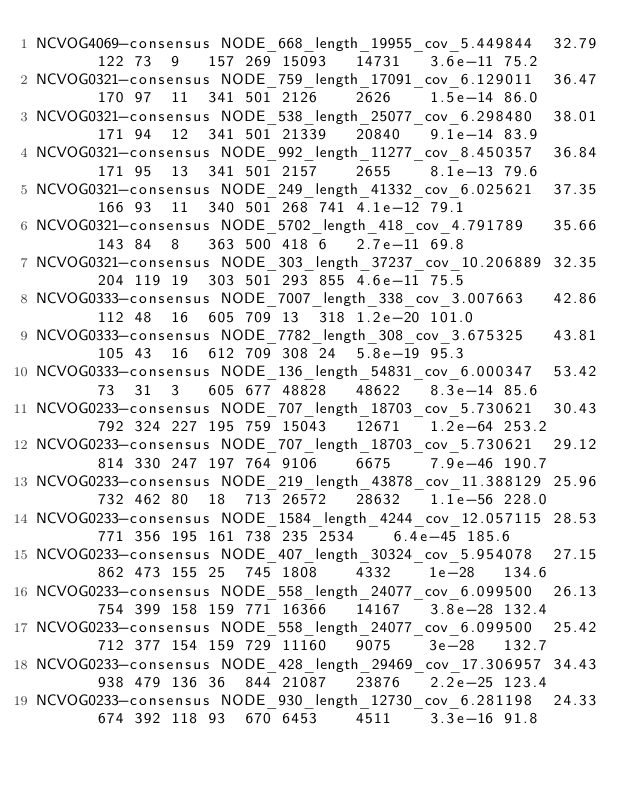Convert code to text. <code><loc_0><loc_0><loc_500><loc_500><_SQL_>NCVOG4069-consensus	NODE_668_length_19955_cov_5.449844	32.79	122	73	9	157	269	15093	14731	3.6e-11	75.2
NCVOG0321-consensus	NODE_759_length_17091_cov_6.129011	36.47	170	97	11	341	501	2126	2626	1.5e-14	86.0
NCVOG0321-consensus	NODE_538_length_25077_cov_6.298480	38.01	171	94	12	341	501	21339	20840	9.1e-14	83.9
NCVOG0321-consensus	NODE_992_length_11277_cov_8.450357	36.84	171	95	13	341	501	2157	2655	8.1e-13	79.6
NCVOG0321-consensus	NODE_249_length_41332_cov_6.025621	37.35	166	93	11	340	501	268	741	4.1e-12	79.1
NCVOG0321-consensus	NODE_5702_length_418_cov_4.791789	35.66	143	84	8	363	500	418	6	2.7e-11	69.8
NCVOG0321-consensus	NODE_303_length_37237_cov_10.206889	32.35	204	119	19	303	501	293	855	4.6e-11	75.5
NCVOG0333-consensus	NODE_7007_length_338_cov_3.007663	42.86	112	48	16	605	709	13	318	1.2e-20	101.0
NCVOG0333-consensus	NODE_7782_length_308_cov_3.675325	43.81	105	43	16	612	709	308	24	5.8e-19	95.3
NCVOG0333-consensus	NODE_136_length_54831_cov_6.000347	53.42	73	31	3	605	677	48828	48622	8.3e-14	85.6
NCVOG0233-consensus	NODE_707_length_18703_cov_5.730621	30.43	792	324	227	195	759	15043	12671	1.2e-64	253.2
NCVOG0233-consensus	NODE_707_length_18703_cov_5.730621	29.12	814	330	247	197	764	9106	6675	7.9e-46	190.7
NCVOG0233-consensus	NODE_219_length_43878_cov_11.388129	25.96	732	462	80	18	713	26572	28632	1.1e-56	228.0
NCVOG0233-consensus	NODE_1584_length_4244_cov_12.057115	28.53	771	356	195	161	738	235	2534	6.4e-45	185.6
NCVOG0233-consensus	NODE_407_length_30324_cov_5.954078	27.15	862	473	155	25	745	1808	4332	1e-28	134.6
NCVOG0233-consensus	NODE_558_length_24077_cov_6.099500	26.13	754	399	158	159	771	16366	14167	3.8e-28	132.4
NCVOG0233-consensus	NODE_558_length_24077_cov_6.099500	25.42	712	377	154	159	729	11160	9075	3e-28	132.7
NCVOG0233-consensus	NODE_428_length_29469_cov_17.306957	34.43	938	479	136	36	844	21087	23876	2.2e-25	123.4
NCVOG0233-consensus	NODE_930_length_12730_cov_6.281198	24.33	674	392	118	93	670	6453	4511	3.3e-16	91.8</code> 